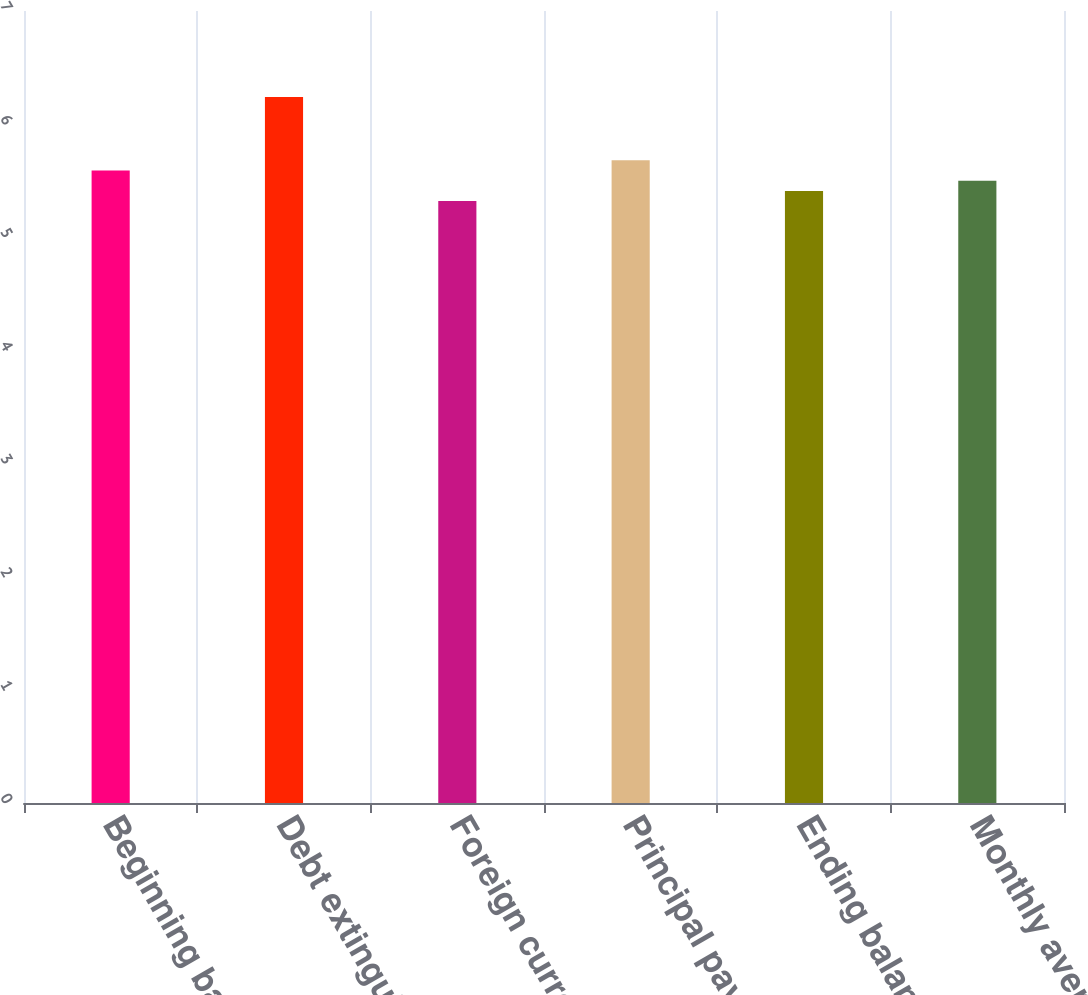Convert chart. <chart><loc_0><loc_0><loc_500><loc_500><bar_chart><fcel>Beginning balance<fcel>Debt extinguished<fcel>Foreign currency<fcel>Principal payments<fcel>Ending balance<fcel>Monthly averages<nl><fcel>5.59<fcel>6.24<fcel>5.32<fcel>5.68<fcel>5.41<fcel>5.5<nl></chart> 